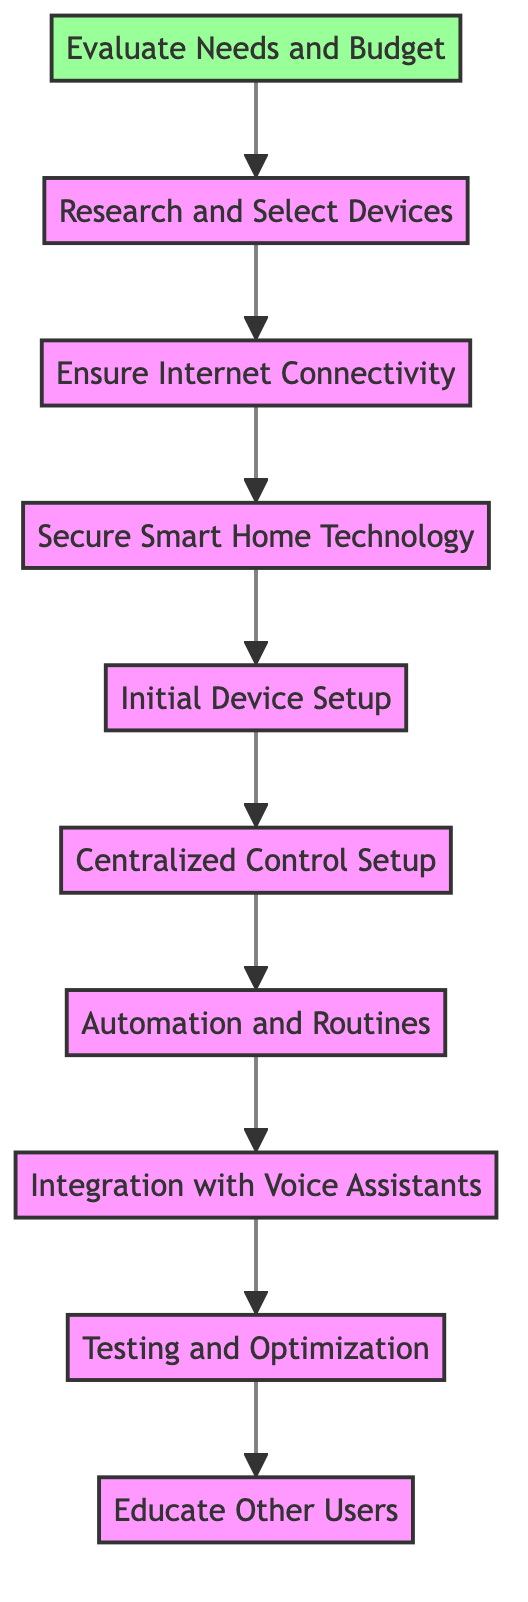What is the first step in the process? The first step in the flowchart is labeled as "Evaluate Needs and Budget," which is the starting point of the diagram.
Answer: Evaluate Needs and Budget How many nodes are there in total? The flowchart consists of ten nodes, each representing a step in setting up a smart home system.
Answer: 10 What follows the "Centralized Control Setup"? The next step following "Centralized Control Setup" is "Automation and Routines," which shows how devices can be automated after the central system is set up.
Answer: Automation and Routines Which step involves security measures? The step that includes security measures is "Secure Smart Home Technology," indicating the importance of securing smart devices.
Answer: Secure Smart Home Technology What is the last step of the instruction? The final step in the flowchart is "Educate Other Users," which focuses on informing family members about using the smart home system.
Answer: Educate Other Users If "Ensure Internet Connectivity" is skipped, which step can be directly reached? If the step "Ensure Internet Connectivity" is skipped, the next step that can be reached is "Secure Smart Home Technology," the subsequent step in the flow.
Answer: Secure Smart Home Technology Which two steps are used to connect smart devices? The two steps involved in connecting smart devices are "Initial Device Setup" and "Centralized Control Setup," which encompass the installation and configuration of devices.
Answer: Initial Device Setup, Centralized Control Setup How does the flowchart indicate the importance of user education? The flowchart emphasizes user education by positioning "Educate Other Users" as the last step, highlighting its significance after all technical setups are completed.
Answer: Educate Other Users How is the relationship between "Research and Select Devices" and "Evaluate Needs and Budget"? The relationship is that "Research and Select Devices" directly follows "Evaluate Needs and Budget," indicating that identifying needs and budget informs the selection process of devices.
Answer: Research and Select Devices 